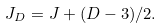Convert formula to latex. <formula><loc_0><loc_0><loc_500><loc_500>J _ { D } = J + ( D - 3 ) / 2 .</formula> 